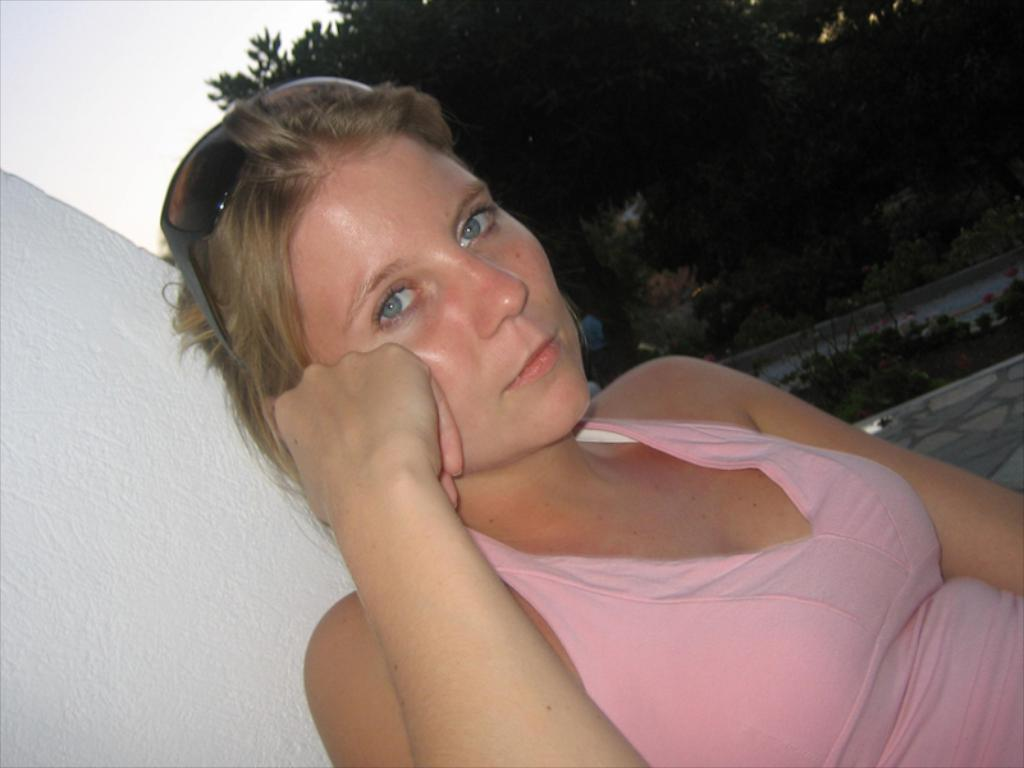Who is the main subject in the image? There is a woman in the front of the image. What can be seen in the background of the image? There are trees and plants in the background of the image. What part of the natural environment is visible in the image? The sky is visible at the top left of the image. What type of insurance policy is the woman holding in the image? There is no indication in the image that the woman is holding any insurance policy. 